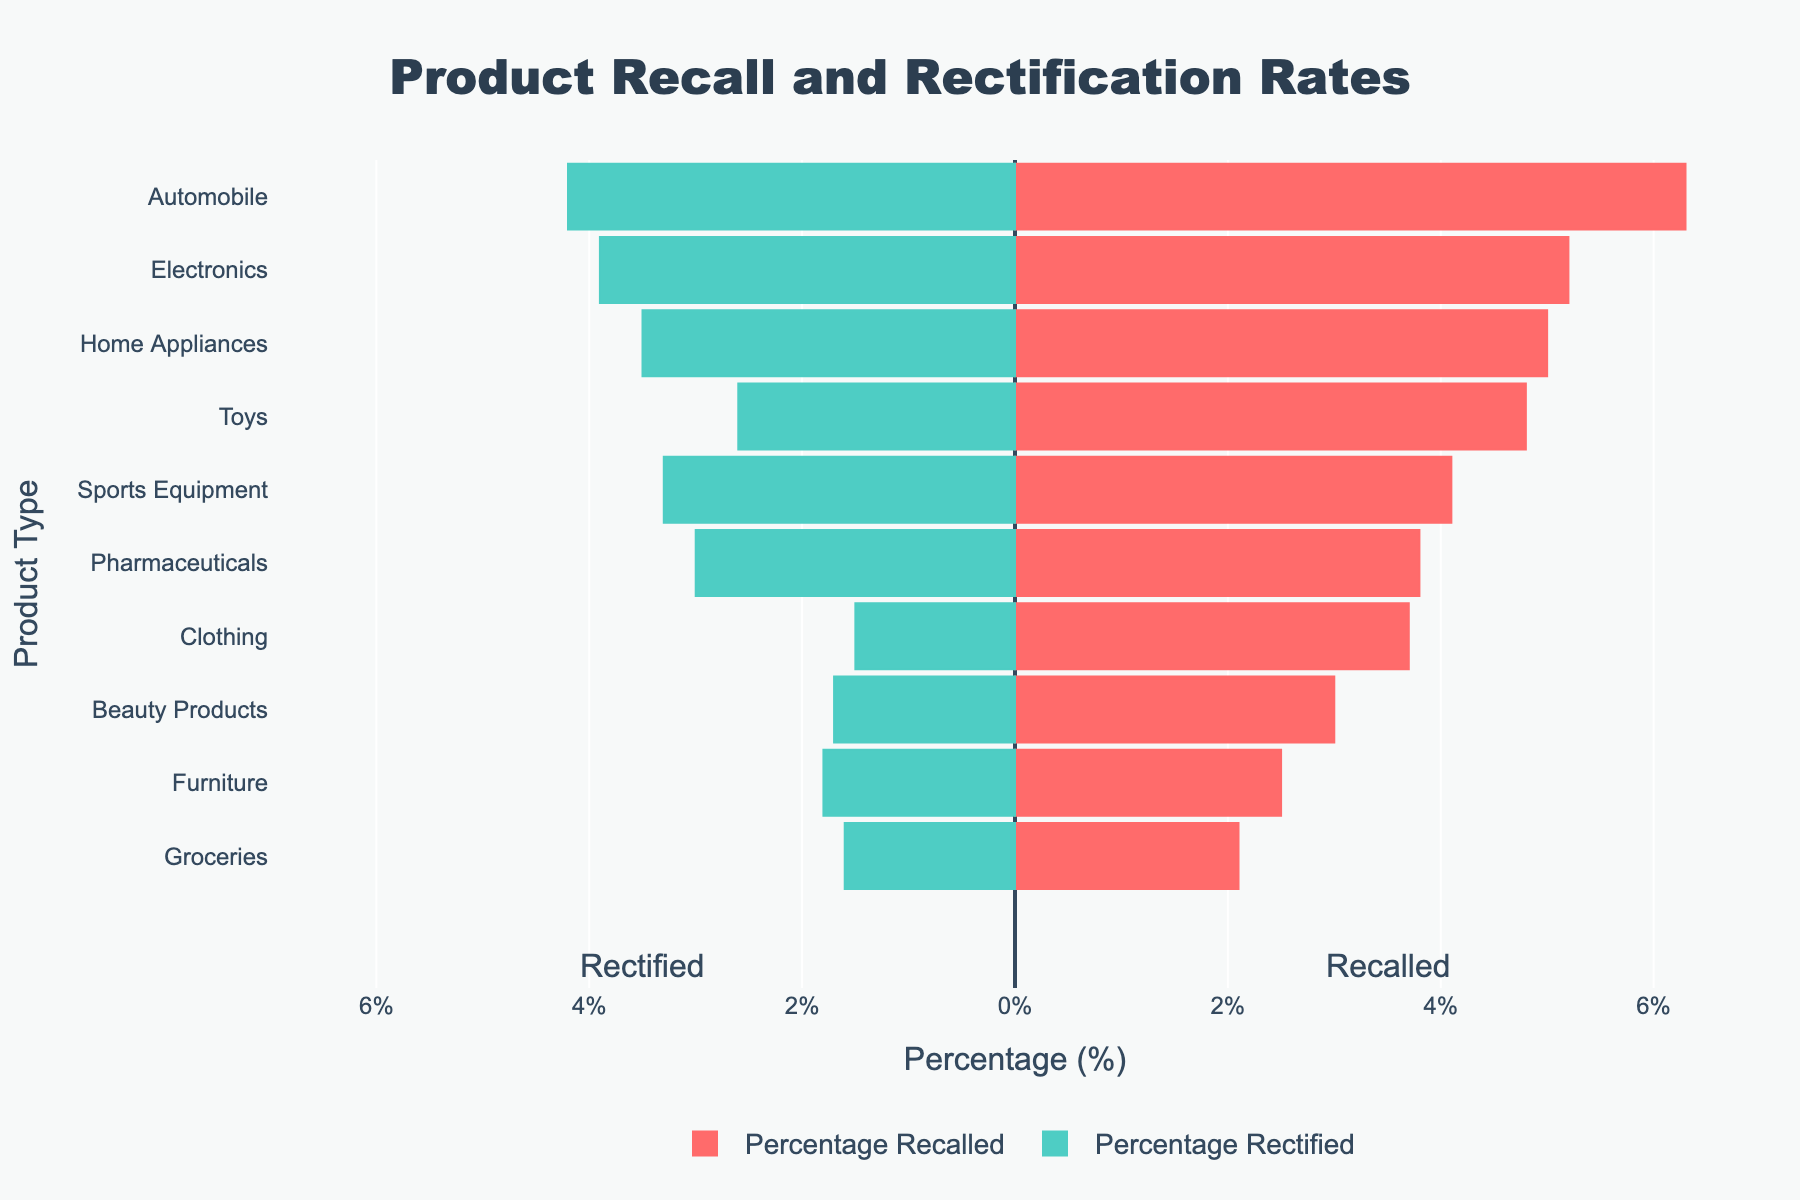Which product type has the highest percentage of recalls? The diverging bar chart shows that "Automobile" has the longest red bar, representing the highest percentage of recalls at 6.3%.
Answer: Automobile What is the difference between the percentage recalled and percentage rectified for Electronics? Electronics has a percentage recalled of 5.2% and a percentage rectified of 3.9%, so the difference is 5.2% - 3.9% = 1.3%.
Answer: 1.3% Which product type has a higher percentage of recalls, Toys or Home Appliances? Toys have a percentage of recalls at 4.8%, while Home Appliances have 5.0%. Therefore, Home Appliances have a higher percentage of recalls.
Answer: Home Appliances What is the combined percentage of recalls for Clothing and Beauty Products? The percentage of recalls for Clothing is 3.7% and for Beauty Products is 3.0%. Adding these together gives 3.7% + 3.0% = 6.7%.
Answer: 6.7% Which product category has a longer green bar, indicating a higher rectification rate, Pharmaceuticals or Furniture? Pharmaceuticals have a higher rectification rate with a green bar representing 3.0%, whereas Furniture has 1.8%. Therefore, Pharmaceuticals have a longer green bar.
Answer: Pharmaceuticals What is the average percentage of recertification for the three product types with the highest recall rates (Automobiles, Electronics, Home Appliances)? The rectification rates for the three product types are Automobiles (4.2%), Electronics (3.9%), and Home Appliances (3.5%). The average is calculated as (4.2% + 3.9% + 3.5%) / 3 = 3.87%.
Answer: 3.87% For which two product types are the percentages of recalls and rectifications closest to each other? For both Electronics and Pharmaceuticals, the difference between the percentages of recalls and rectifications is relatively small: Electronics (5.2% - 3.9% = 1.3%) and Pharmaceuticals (3.8% - 3.0% = 0.8%). Of these, Pharmaceuticals has the smallest difference.
Answer: Pharmaceuticals Do more than 5 product types have a rectification rate of 2% or higher? Based on the green bars (representing rectified percentages), the product types with rectification rates of 2% or higher are Electronics, Automobiles, Sports Equipment, Pharmaceuticals, and Home Appliances, making exactly 5 products.
Answer: No Is the rectification rate for Groceries higher or lower than the recall rate for Beauty Products? The rectification rate for Groceries is 1.6%, while the recall rate for Beauty Products is 3.0%. The rectification rate for Groceries is lower.
Answer: Lower Which product type has the smallest percentage of recalls and what is its value? The product type "Groceries" has the smallest percentage of recalls, which is shown by the shortest red bar at 2.1%.
Answer: Groceries (2.1%) 